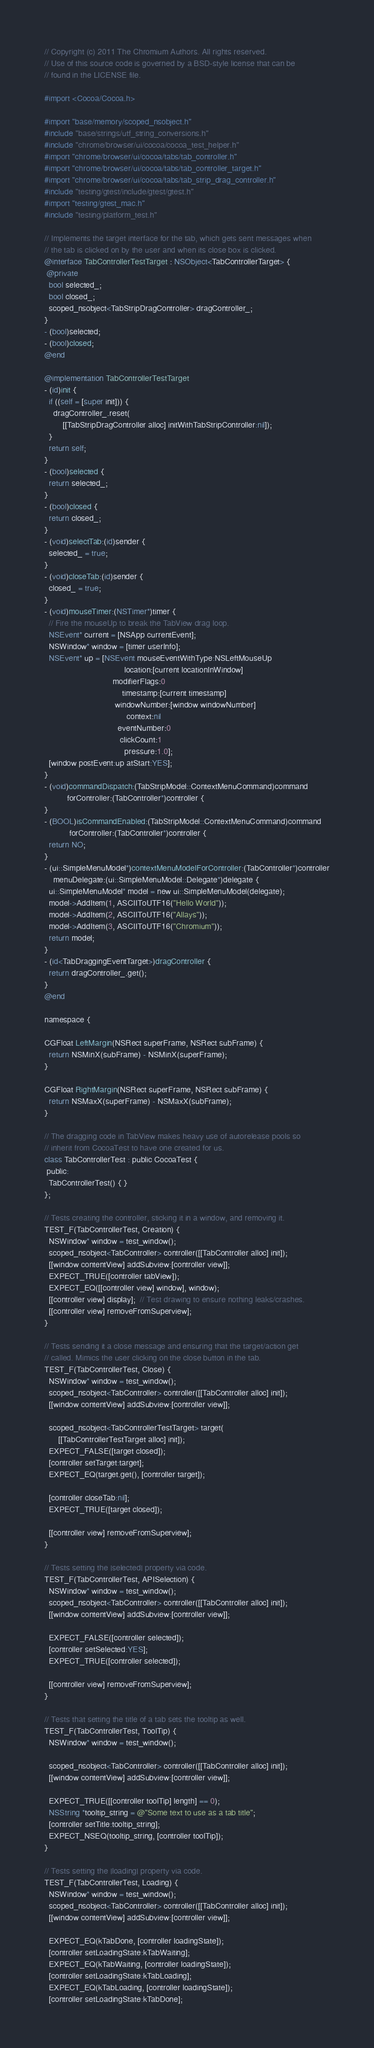Convert code to text. <code><loc_0><loc_0><loc_500><loc_500><_ObjectiveC_>// Copyright (c) 2011 The Chromium Authors. All rights reserved.
// Use of this source code is governed by a BSD-style license that can be
// found in the LICENSE file.

#import <Cocoa/Cocoa.h>

#import "base/memory/scoped_nsobject.h"
#include "base/strings/utf_string_conversions.h"
#include "chrome/browser/ui/cocoa/cocoa_test_helper.h"
#import "chrome/browser/ui/cocoa/tabs/tab_controller.h"
#import "chrome/browser/ui/cocoa/tabs/tab_controller_target.h"
#import "chrome/browser/ui/cocoa/tabs/tab_strip_drag_controller.h"
#include "testing/gtest/include/gtest/gtest.h"
#import "testing/gtest_mac.h"
#include "testing/platform_test.h"

// Implements the target interface for the tab, which gets sent messages when
// the tab is clicked on by the user and when its close box is clicked.
@interface TabControllerTestTarget : NSObject<TabControllerTarget> {
 @private
  bool selected_;
  bool closed_;
  scoped_nsobject<TabStripDragController> dragController_;
}
- (bool)selected;
- (bool)closed;
@end

@implementation TabControllerTestTarget
- (id)init {
  if ((self = [super init])) {
    dragController_.reset(
        [[TabStripDragController alloc] initWithTabStripController:nil]);
  }
  return self;
}
- (bool)selected {
  return selected_;
}
- (bool)closed {
  return closed_;
}
- (void)selectTab:(id)sender {
  selected_ = true;
}
- (void)closeTab:(id)sender {
  closed_ = true;
}
- (void)mouseTimer:(NSTimer*)timer {
  // Fire the mouseUp to break the TabView drag loop.
  NSEvent* current = [NSApp currentEvent];
  NSWindow* window = [timer userInfo];
  NSEvent* up = [NSEvent mouseEventWithType:NSLeftMouseUp
                                   location:[current locationInWindow]
                              modifierFlags:0
                                  timestamp:[current timestamp]
                               windowNumber:[window windowNumber]
                                    context:nil
                                eventNumber:0
                                 clickCount:1
                                   pressure:1.0];
  [window postEvent:up atStart:YES];
}
- (void)commandDispatch:(TabStripModel::ContextMenuCommand)command
          forController:(TabController*)controller {
}
- (BOOL)isCommandEnabled:(TabStripModel::ContextMenuCommand)command
           forController:(TabController*)controller {
  return NO;
}
- (ui::SimpleMenuModel*)contextMenuModelForController:(TabController*)controller
    menuDelegate:(ui::SimpleMenuModel::Delegate*)delegate {
  ui::SimpleMenuModel* model = new ui::SimpleMenuModel(delegate);
  model->AddItem(1, ASCIIToUTF16("Hello World"));
  model->AddItem(2, ASCIIToUTF16("Allays"));
  model->AddItem(3, ASCIIToUTF16("Chromium"));
  return model;
}
- (id<TabDraggingEventTarget>)dragController {
  return dragController_.get();
}
@end

namespace {

CGFloat LeftMargin(NSRect superFrame, NSRect subFrame) {
  return NSMinX(subFrame) - NSMinX(superFrame);
}

CGFloat RightMargin(NSRect superFrame, NSRect subFrame) {
  return NSMaxX(superFrame) - NSMaxX(subFrame);
}

// The dragging code in TabView makes heavy use of autorelease pools so
// inherit from CocoaTest to have one created for us.
class TabControllerTest : public CocoaTest {
 public:
  TabControllerTest() { }
};

// Tests creating the controller, sticking it in a window, and removing it.
TEST_F(TabControllerTest, Creation) {
  NSWindow* window = test_window();
  scoped_nsobject<TabController> controller([[TabController alloc] init]);
  [[window contentView] addSubview:[controller view]];
  EXPECT_TRUE([controller tabView]);
  EXPECT_EQ([[controller view] window], window);
  [[controller view] display];  // Test drawing to ensure nothing leaks/crashes.
  [[controller view] removeFromSuperview];
}

// Tests sending it a close message and ensuring that the target/action get
// called. Mimics the user clicking on the close button in the tab.
TEST_F(TabControllerTest, Close) {
  NSWindow* window = test_window();
  scoped_nsobject<TabController> controller([[TabController alloc] init]);
  [[window contentView] addSubview:[controller view]];

  scoped_nsobject<TabControllerTestTarget> target(
      [[TabControllerTestTarget alloc] init]);
  EXPECT_FALSE([target closed]);
  [controller setTarget:target];
  EXPECT_EQ(target.get(), [controller target]);

  [controller closeTab:nil];
  EXPECT_TRUE([target closed]);

  [[controller view] removeFromSuperview];
}

// Tests setting the |selected| property via code.
TEST_F(TabControllerTest, APISelection) {
  NSWindow* window = test_window();
  scoped_nsobject<TabController> controller([[TabController alloc] init]);
  [[window contentView] addSubview:[controller view]];

  EXPECT_FALSE([controller selected]);
  [controller setSelected:YES];
  EXPECT_TRUE([controller selected]);

  [[controller view] removeFromSuperview];
}

// Tests that setting the title of a tab sets the tooltip as well.
TEST_F(TabControllerTest, ToolTip) {
  NSWindow* window = test_window();

  scoped_nsobject<TabController> controller([[TabController alloc] init]);
  [[window contentView] addSubview:[controller view]];

  EXPECT_TRUE([[controller toolTip] length] == 0);
  NSString *tooltip_string = @"Some text to use as a tab title";
  [controller setTitle:tooltip_string];
  EXPECT_NSEQ(tooltip_string, [controller toolTip]);
}

// Tests setting the |loading| property via code.
TEST_F(TabControllerTest, Loading) {
  NSWindow* window = test_window();
  scoped_nsobject<TabController> controller([[TabController alloc] init]);
  [[window contentView] addSubview:[controller view]];

  EXPECT_EQ(kTabDone, [controller loadingState]);
  [controller setLoadingState:kTabWaiting];
  EXPECT_EQ(kTabWaiting, [controller loadingState]);
  [controller setLoadingState:kTabLoading];
  EXPECT_EQ(kTabLoading, [controller loadingState]);
  [controller setLoadingState:kTabDone];</code> 